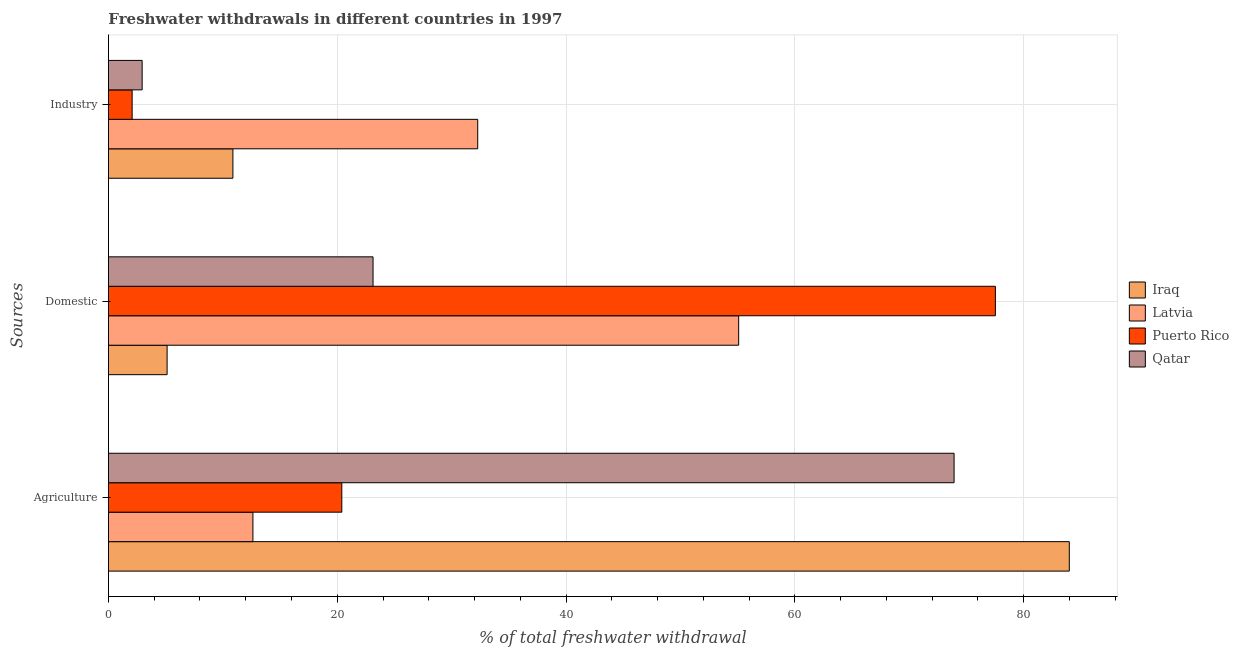How many different coloured bars are there?
Your response must be concise. 4. How many groups of bars are there?
Keep it short and to the point. 3. Are the number of bars per tick equal to the number of legend labels?
Your answer should be very brief. Yes. Are the number of bars on each tick of the Y-axis equal?
Make the answer very short. Yes. How many bars are there on the 2nd tick from the bottom?
Give a very brief answer. 4. What is the label of the 2nd group of bars from the top?
Provide a short and direct response. Domestic. What is the percentage of freshwater withdrawal for agriculture in Iraq?
Your response must be concise. 83.99. Across all countries, what is the maximum percentage of freshwater withdrawal for industry?
Give a very brief answer. 32.28. Across all countries, what is the minimum percentage of freshwater withdrawal for industry?
Provide a succinct answer. 2.07. In which country was the percentage of freshwater withdrawal for domestic purposes maximum?
Offer a very short reply. Puerto Rico. In which country was the percentage of freshwater withdrawal for industry minimum?
Keep it short and to the point. Puerto Rico. What is the total percentage of freshwater withdrawal for industry in the graph?
Ensure brevity in your answer.  48.18. What is the difference between the percentage of freshwater withdrawal for industry in Puerto Rico and that in Latvia?
Offer a terse response. -30.21. What is the difference between the percentage of freshwater withdrawal for agriculture in Puerto Rico and the percentage of freshwater withdrawal for domestic purposes in Latvia?
Keep it short and to the point. -34.69. What is the average percentage of freshwater withdrawal for industry per country?
Offer a very short reply. 12.05. What is the difference between the percentage of freshwater withdrawal for industry and percentage of freshwater withdrawal for agriculture in Latvia?
Make the answer very short. 19.65. What is the ratio of the percentage of freshwater withdrawal for domestic purposes in Iraq to that in Puerto Rico?
Your answer should be compact. 0.07. Is the percentage of freshwater withdrawal for domestic purposes in Qatar less than that in Iraq?
Your answer should be very brief. No. What is the difference between the highest and the second highest percentage of freshwater withdrawal for domestic purposes?
Your answer should be compact. 22.44. What is the difference between the highest and the lowest percentage of freshwater withdrawal for industry?
Offer a very short reply. 30.21. In how many countries, is the percentage of freshwater withdrawal for industry greater than the average percentage of freshwater withdrawal for industry taken over all countries?
Provide a succinct answer. 1. Is the sum of the percentage of freshwater withdrawal for domestic purposes in Iraq and Puerto Rico greater than the maximum percentage of freshwater withdrawal for industry across all countries?
Your answer should be very brief. Yes. What does the 2nd bar from the top in Industry represents?
Your answer should be very brief. Puerto Rico. What does the 1st bar from the bottom in Industry represents?
Provide a succinct answer. Iraq. Is it the case that in every country, the sum of the percentage of freshwater withdrawal for agriculture and percentage of freshwater withdrawal for domestic purposes is greater than the percentage of freshwater withdrawal for industry?
Offer a terse response. Yes. How many bars are there?
Give a very brief answer. 12. How many countries are there in the graph?
Your answer should be very brief. 4. Are the values on the major ticks of X-axis written in scientific E-notation?
Your answer should be very brief. No. Does the graph contain any zero values?
Provide a short and direct response. No. Where does the legend appear in the graph?
Ensure brevity in your answer.  Center right. What is the title of the graph?
Provide a short and direct response. Freshwater withdrawals in different countries in 1997. What is the label or title of the X-axis?
Your response must be concise. % of total freshwater withdrawal. What is the label or title of the Y-axis?
Your answer should be compact. Sources. What is the % of total freshwater withdrawal in Iraq in Agriculture?
Your response must be concise. 83.99. What is the % of total freshwater withdrawal of Latvia in Agriculture?
Provide a short and direct response. 12.63. What is the % of total freshwater withdrawal of Puerto Rico in Agriculture?
Keep it short and to the point. 20.4. What is the % of total freshwater withdrawal in Qatar in Agriculture?
Offer a terse response. 73.92. What is the % of total freshwater withdrawal in Iraq in Domestic?
Give a very brief answer. 5.13. What is the % of total freshwater withdrawal in Latvia in Domestic?
Provide a short and direct response. 55.09. What is the % of total freshwater withdrawal of Puerto Rico in Domestic?
Provide a short and direct response. 77.53. What is the % of total freshwater withdrawal in Qatar in Domestic?
Make the answer very short. 23.13. What is the % of total freshwater withdrawal in Iraq in Industry?
Offer a terse response. 10.88. What is the % of total freshwater withdrawal of Latvia in Industry?
Your answer should be compact. 32.28. What is the % of total freshwater withdrawal of Puerto Rico in Industry?
Make the answer very short. 2.07. What is the % of total freshwater withdrawal in Qatar in Industry?
Your answer should be very brief. 2.95. Across all Sources, what is the maximum % of total freshwater withdrawal in Iraq?
Your response must be concise. 83.99. Across all Sources, what is the maximum % of total freshwater withdrawal in Latvia?
Your answer should be very brief. 55.09. Across all Sources, what is the maximum % of total freshwater withdrawal in Puerto Rico?
Give a very brief answer. 77.53. Across all Sources, what is the maximum % of total freshwater withdrawal in Qatar?
Your response must be concise. 73.92. Across all Sources, what is the minimum % of total freshwater withdrawal of Iraq?
Your answer should be very brief. 5.13. Across all Sources, what is the minimum % of total freshwater withdrawal in Latvia?
Ensure brevity in your answer.  12.63. Across all Sources, what is the minimum % of total freshwater withdrawal of Puerto Rico?
Offer a terse response. 2.07. Across all Sources, what is the minimum % of total freshwater withdrawal of Qatar?
Make the answer very short. 2.95. What is the total % of total freshwater withdrawal of Iraq in the graph?
Make the answer very short. 100. What is the total % of total freshwater withdrawal of Puerto Rico in the graph?
Provide a short and direct response. 100. What is the total % of total freshwater withdrawal of Qatar in the graph?
Offer a very short reply. 100. What is the difference between the % of total freshwater withdrawal of Iraq in Agriculture and that in Domestic?
Make the answer very short. 78.86. What is the difference between the % of total freshwater withdrawal in Latvia in Agriculture and that in Domestic?
Your response must be concise. -42.46. What is the difference between the % of total freshwater withdrawal of Puerto Rico in Agriculture and that in Domestic?
Keep it short and to the point. -57.13. What is the difference between the % of total freshwater withdrawal of Qatar in Agriculture and that in Domestic?
Your response must be concise. 50.79. What is the difference between the % of total freshwater withdrawal in Iraq in Agriculture and that in Industry?
Your answer should be compact. 73.11. What is the difference between the % of total freshwater withdrawal of Latvia in Agriculture and that in Industry?
Your answer should be compact. -19.65. What is the difference between the % of total freshwater withdrawal in Puerto Rico in Agriculture and that in Industry?
Your response must be concise. 18.33. What is the difference between the % of total freshwater withdrawal of Qatar in Agriculture and that in Industry?
Provide a succinct answer. 70.97. What is the difference between the % of total freshwater withdrawal of Iraq in Domestic and that in Industry?
Keep it short and to the point. -5.75. What is the difference between the % of total freshwater withdrawal in Latvia in Domestic and that in Industry?
Give a very brief answer. 22.81. What is the difference between the % of total freshwater withdrawal of Puerto Rico in Domestic and that in Industry?
Your answer should be very brief. 75.46. What is the difference between the % of total freshwater withdrawal in Qatar in Domestic and that in Industry?
Make the answer very short. 20.18. What is the difference between the % of total freshwater withdrawal in Iraq in Agriculture and the % of total freshwater withdrawal in Latvia in Domestic?
Provide a short and direct response. 28.9. What is the difference between the % of total freshwater withdrawal in Iraq in Agriculture and the % of total freshwater withdrawal in Puerto Rico in Domestic?
Offer a very short reply. 6.46. What is the difference between the % of total freshwater withdrawal of Iraq in Agriculture and the % of total freshwater withdrawal of Qatar in Domestic?
Offer a very short reply. 60.86. What is the difference between the % of total freshwater withdrawal in Latvia in Agriculture and the % of total freshwater withdrawal in Puerto Rico in Domestic?
Ensure brevity in your answer.  -64.9. What is the difference between the % of total freshwater withdrawal in Puerto Rico in Agriculture and the % of total freshwater withdrawal in Qatar in Domestic?
Your response must be concise. -2.73. What is the difference between the % of total freshwater withdrawal of Iraq in Agriculture and the % of total freshwater withdrawal of Latvia in Industry?
Offer a very short reply. 51.71. What is the difference between the % of total freshwater withdrawal of Iraq in Agriculture and the % of total freshwater withdrawal of Puerto Rico in Industry?
Ensure brevity in your answer.  81.92. What is the difference between the % of total freshwater withdrawal of Iraq in Agriculture and the % of total freshwater withdrawal of Qatar in Industry?
Provide a succinct answer. 81.04. What is the difference between the % of total freshwater withdrawal in Latvia in Agriculture and the % of total freshwater withdrawal in Puerto Rico in Industry?
Keep it short and to the point. 10.56. What is the difference between the % of total freshwater withdrawal in Latvia in Agriculture and the % of total freshwater withdrawal in Qatar in Industry?
Give a very brief answer. 9.68. What is the difference between the % of total freshwater withdrawal of Puerto Rico in Agriculture and the % of total freshwater withdrawal of Qatar in Industry?
Provide a succinct answer. 17.45. What is the difference between the % of total freshwater withdrawal in Iraq in Domestic and the % of total freshwater withdrawal in Latvia in Industry?
Give a very brief answer. -27.15. What is the difference between the % of total freshwater withdrawal of Iraq in Domestic and the % of total freshwater withdrawal of Puerto Rico in Industry?
Provide a succinct answer. 3.06. What is the difference between the % of total freshwater withdrawal in Iraq in Domestic and the % of total freshwater withdrawal in Qatar in Industry?
Keep it short and to the point. 2.18. What is the difference between the % of total freshwater withdrawal of Latvia in Domestic and the % of total freshwater withdrawal of Puerto Rico in Industry?
Provide a succinct answer. 53.02. What is the difference between the % of total freshwater withdrawal of Latvia in Domestic and the % of total freshwater withdrawal of Qatar in Industry?
Ensure brevity in your answer.  52.14. What is the difference between the % of total freshwater withdrawal in Puerto Rico in Domestic and the % of total freshwater withdrawal in Qatar in Industry?
Make the answer very short. 74.58. What is the average % of total freshwater withdrawal in Iraq per Sources?
Your answer should be very brief. 33.33. What is the average % of total freshwater withdrawal in Latvia per Sources?
Provide a short and direct response. 33.33. What is the average % of total freshwater withdrawal of Puerto Rico per Sources?
Your answer should be compact. 33.33. What is the average % of total freshwater withdrawal in Qatar per Sources?
Provide a short and direct response. 33.33. What is the difference between the % of total freshwater withdrawal in Iraq and % of total freshwater withdrawal in Latvia in Agriculture?
Ensure brevity in your answer.  71.36. What is the difference between the % of total freshwater withdrawal in Iraq and % of total freshwater withdrawal in Puerto Rico in Agriculture?
Offer a terse response. 63.59. What is the difference between the % of total freshwater withdrawal in Iraq and % of total freshwater withdrawal in Qatar in Agriculture?
Keep it short and to the point. 10.07. What is the difference between the % of total freshwater withdrawal of Latvia and % of total freshwater withdrawal of Puerto Rico in Agriculture?
Your answer should be compact. -7.77. What is the difference between the % of total freshwater withdrawal in Latvia and % of total freshwater withdrawal in Qatar in Agriculture?
Provide a succinct answer. -61.29. What is the difference between the % of total freshwater withdrawal of Puerto Rico and % of total freshwater withdrawal of Qatar in Agriculture?
Provide a succinct answer. -53.52. What is the difference between the % of total freshwater withdrawal of Iraq and % of total freshwater withdrawal of Latvia in Domestic?
Provide a succinct answer. -49.96. What is the difference between the % of total freshwater withdrawal of Iraq and % of total freshwater withdrawal of Puerto Rico in Domestic?
Provide a succinct answer. -72.4. What is the difference between the % of total freshwater withdrawal in Iraq and % of total freshwater withdrawal in Qatar in Domestic?
Ensure brevity in your answer.  -18. What is the difference between the % of total freshwater withdrawal in Latvia and % of total freshwater withdrawal in Puerto Rico in Domestic?
Your answer should be very brief. -22.44. What is the difference between the % of total freshwater withdrawal in Latvia and % of total freshwater withdrawal in Qatar in Domestic?
Offer a very short reply. 31.96. What is the difference between the % of total freshwater withdrawal in Puerto Rico and % of total freshwater withdrawal in Qatar in Domestic?
Your response must be concise. 54.4. What is the difference between the % of total freshwater withdrawal of Iraq and % of total freshwater withdrawal of Latvia in Industry?
Provide a short and direct response. -21.4. What is the difference between the % of total freshwater withdrawal in Iraq and % of total freshwater withdrawal in Puerto Rico in Industry?
Make the answer very short. 8.81. What is the difference between the % of total freshwater withdrawal in Iraq and % of total freshwater withdrawal in Qatar in Industry?
Ensure brevity in your answer.  7.93. What is the difference between the % of total freshwater withdrawal of Latvia and % of total freshwater withdrawal of Puerto Rico in Industry?
Give a very brief answer. 30.21. What is the difference between the % of total freshwater withdrawal in Latvia and % of total freshwater withdrawal in Qatar in Industry?
Provide a short and direct response. 29.33. What is the difference between the % of total freshwater withdrawal in Puerto Rico and % of total freshwater withdrawal in Qatar in Industry?
Ensure brevity in your answer.  -0.88. What is the ratio of the % of total freshwater withdrawal of Iraq in Agriculture to that in Domestic?
Provide a succinct answer. 16.38. What is the ratio of the % of total freshwater withdrawal in Latvia in Agriculture to that in Domestic?
Keep it short and to the point. 0.23. What is the ratio of the % of total freshwater withdrawal in Puerto Rico in Agriculture to that in Domestic?
Offer a terse response. 0.26. What is the ratio of the % of total freshwater withdrawal of Qatar in Agriculture to that in Domestic?
Your answer should be compact. 3.2. What is the ratio of the % of total freshwater withdrawal of Iraq in Agriculture to that in Industry?
Ensure brevity in your answer.  7.72. What is the ratio of the % of total freshwater withdrawal of Latvia in Agriculture to that in Industry?
Ensure brevity in your answer.  0.39. What is the ratio of the % of total freshwater withdrawal of Puerto Rico in Agriculture to that in Industry?
Provide a succinct answer. 9.85. What is the ratio of the % of total freshwater withdrawal in Qatar in Agriculture to that in Industry?
Your response must be concise. 25.07. What is the ratio of the % of total freshwater withdrawal of Iraq in Domestic to that in Industry?
Give a very brief answer. 0.47. What is the ratio of the % of total freshwater withdrawal of Latvia in Domestic to that in Industry?
Offer a very short reply. 1.71. What is the ratio of the % of total freshwater withdrawal of Puerto Rico in Domestic to that in Industry?
Provide a succinct answer. 37.42. What is the ratio of the % of total freshwater withdrawal in Qatar in Domestic to that in Industry?
Your response must be concise. 7.85. What is the difference between the highest and the second highest % of total freshwater withdrawal in Iraq?
Keep it short and to the point. 73.11. What is the difference between the highest and the second highest % of total freshwater withdrawal in Latvia?
Ensure brevity in your answer.  22.81. What is the difference between the highest and the second highest % of total freshwater withdrawal of Puerto Rico?
Make the answer very short. 57.13. What is the difference between the highest and the second highest % of total freshwater withdrawal of Qatar?
Your answer should be very brief. 50.79. What is the difference between the highest and the lowest % of total freshwater withdrawal in Iraq?
Provide a short and direct response. 78.86. What is the difference between the highest and the lowest % of total freshwater withdrawal in Latvia?
Your answer should be very brief. 42.46. What is the difference between the highest and the lowest % of total freshwater withdrawal in Puerto Rico?
Give a very brief answer. 75.46. What is the difference between the highest and the lowest % of total freshwater withdrawal in Qatar?
Keep it short and to the point. 70.97. 